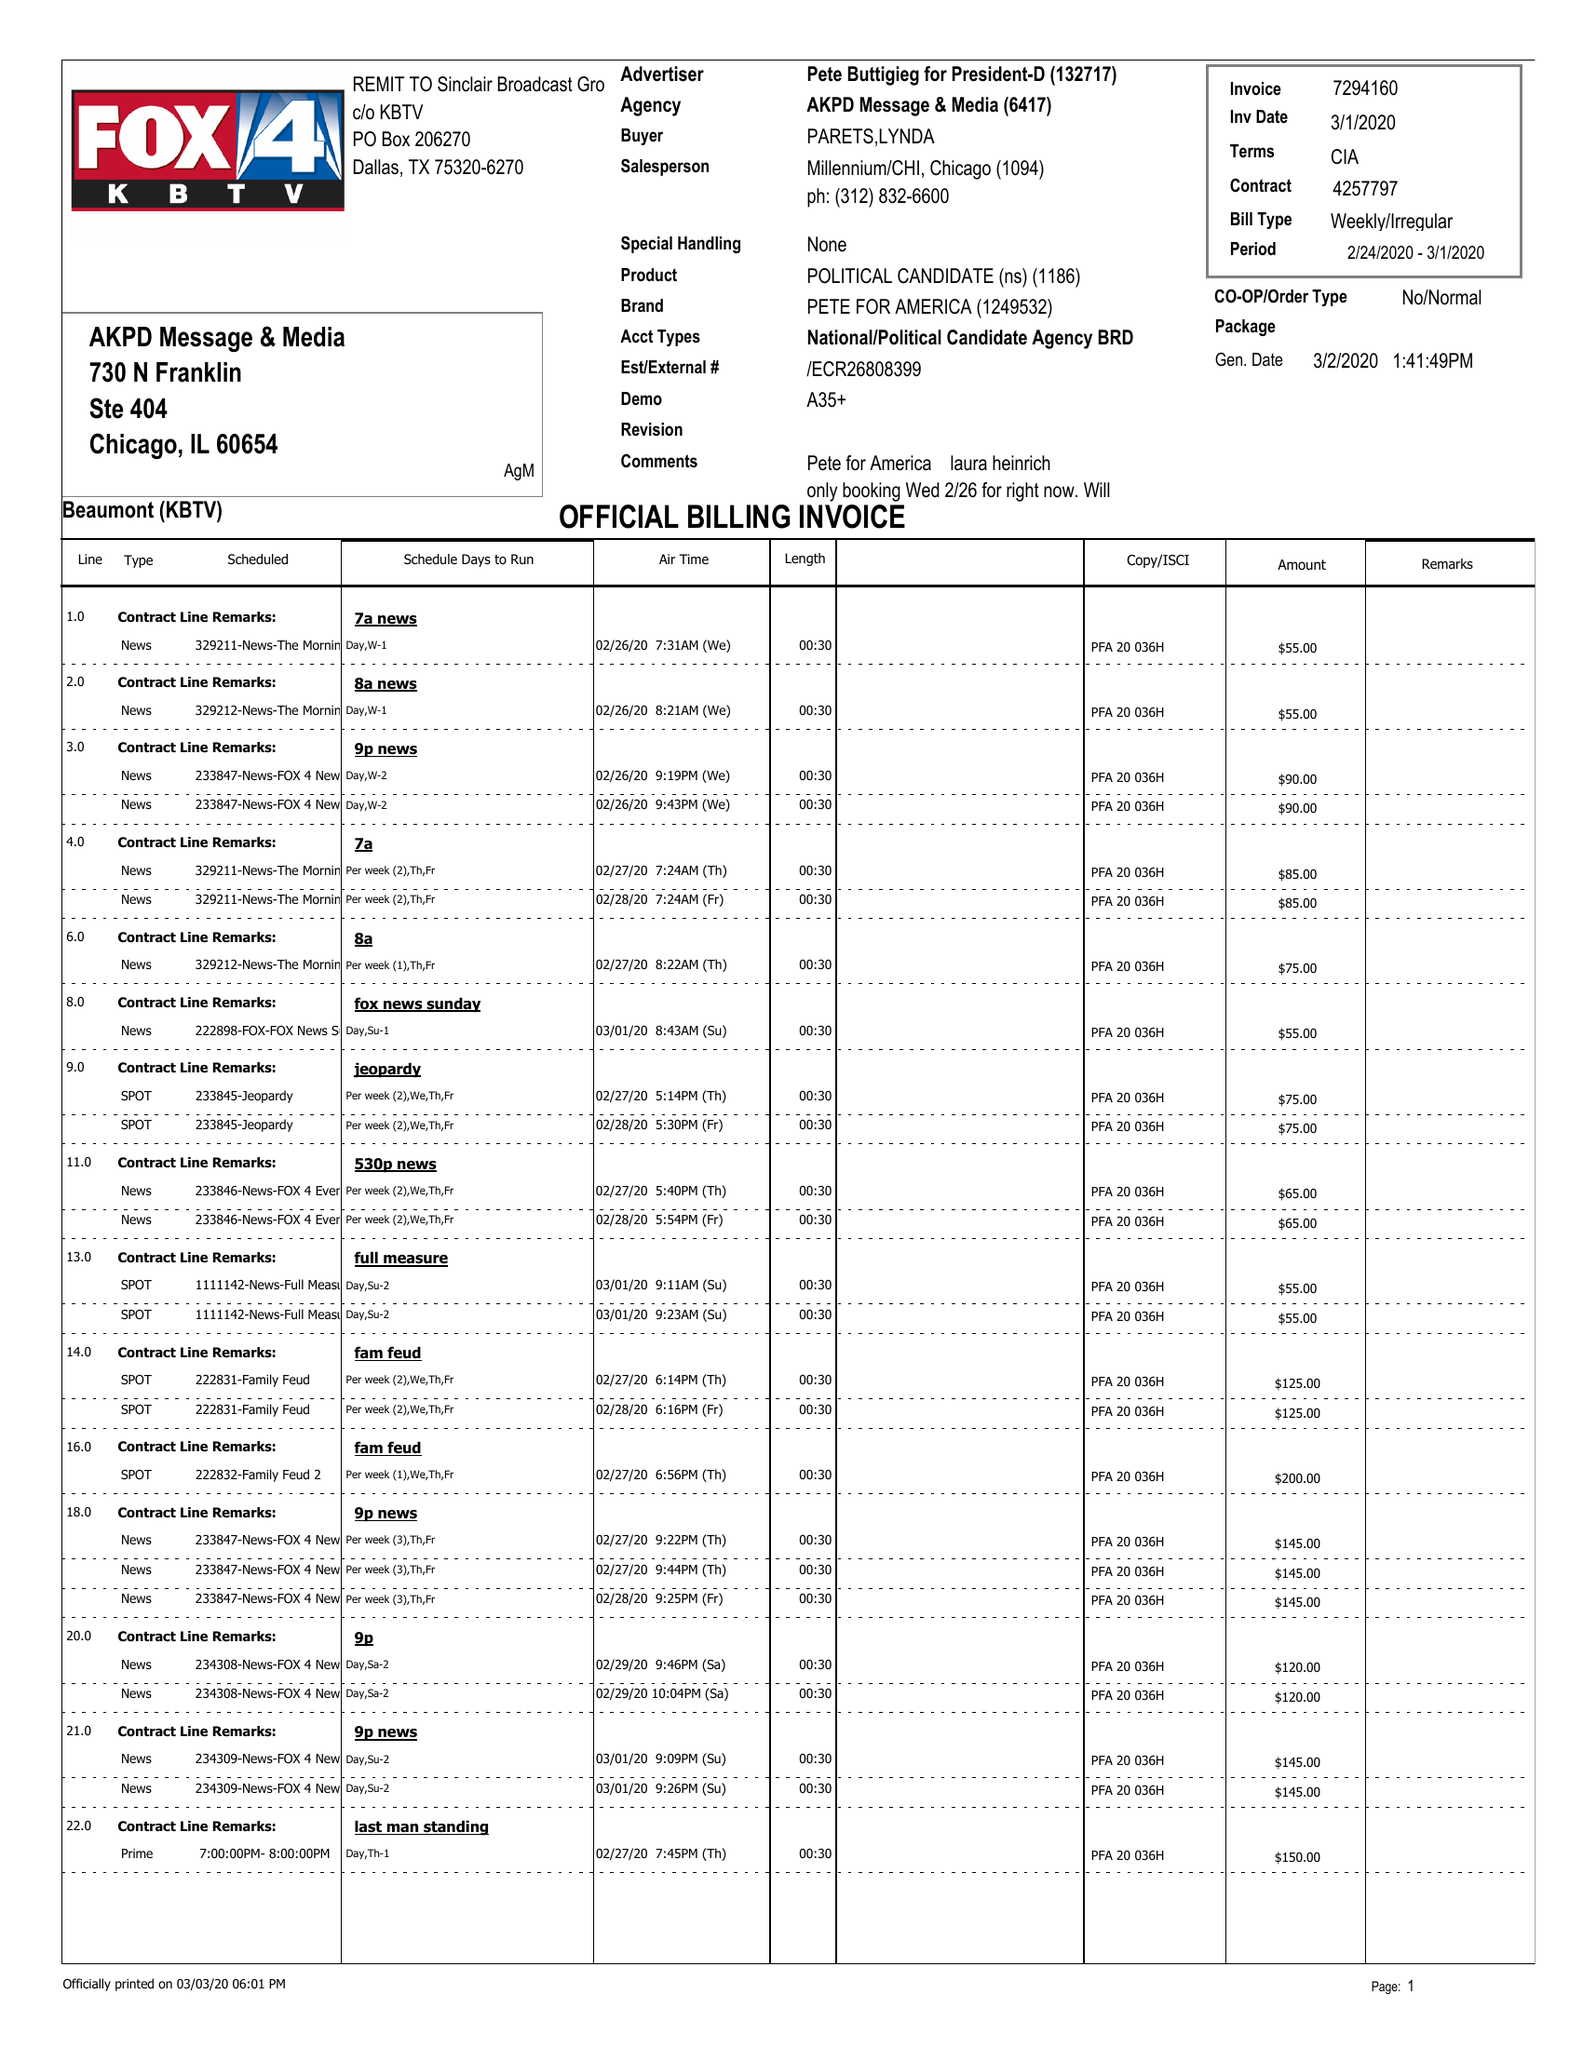What is the value for the advertiser?
Answer the question using a single word or phrase. PETE BUTTIGIEG FOR PRESIDENT-D 